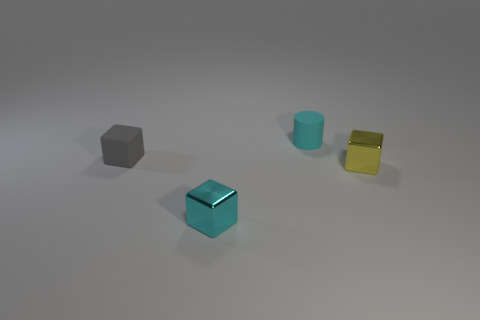Subtract 1 cubes. How many cubes are left? 2 Add 4 red matte balls. How many objects exist? 8 Subtract all blocks. How many objects are left? 1 Add 4 big purple matte things. How many big purple matte things exist? 4 Subtract 0 red blocks. How many objects are left? 4 Subtract all small gray rubber objects. Subtract all cyan cylinders. How many objects are left? 2 Add 1 yellow cubes. How many yellow cubes are left? 2 